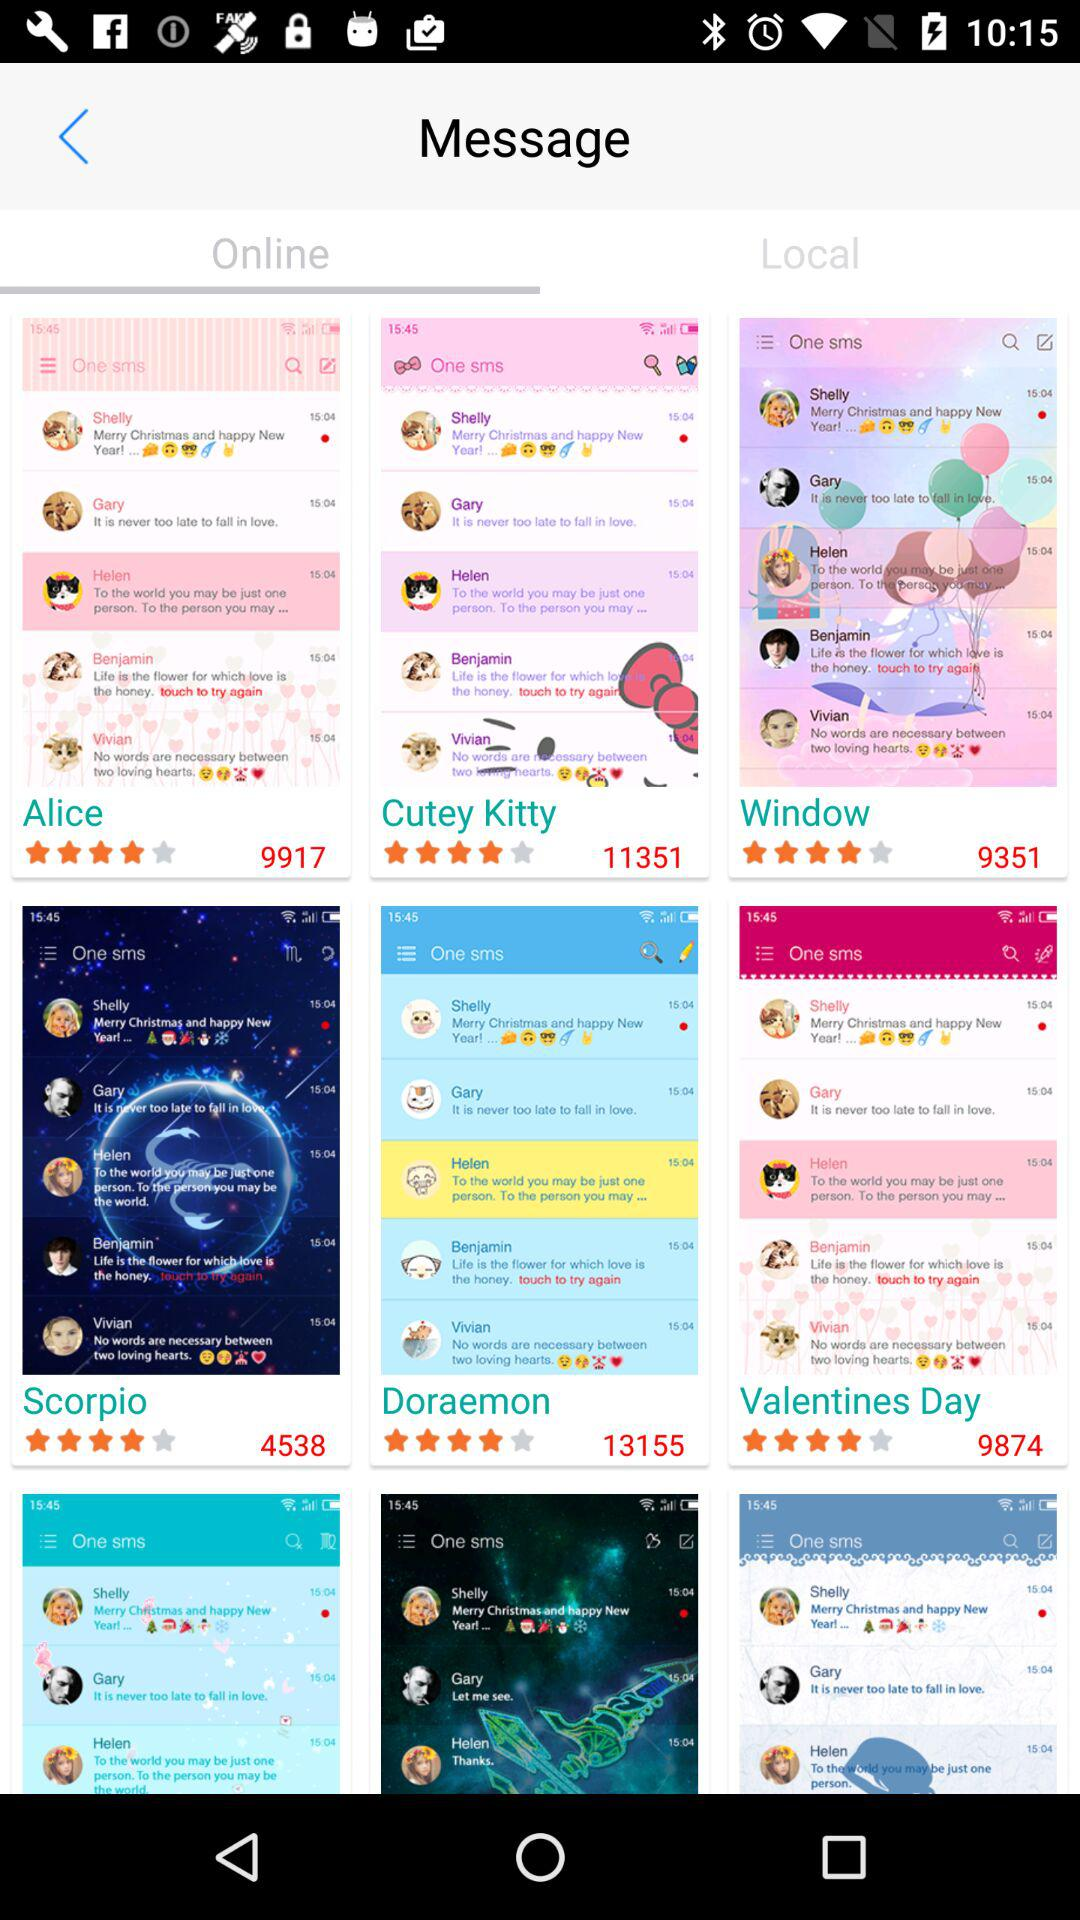What is the rating for "Doraemon"? The rating is 4 stars. 